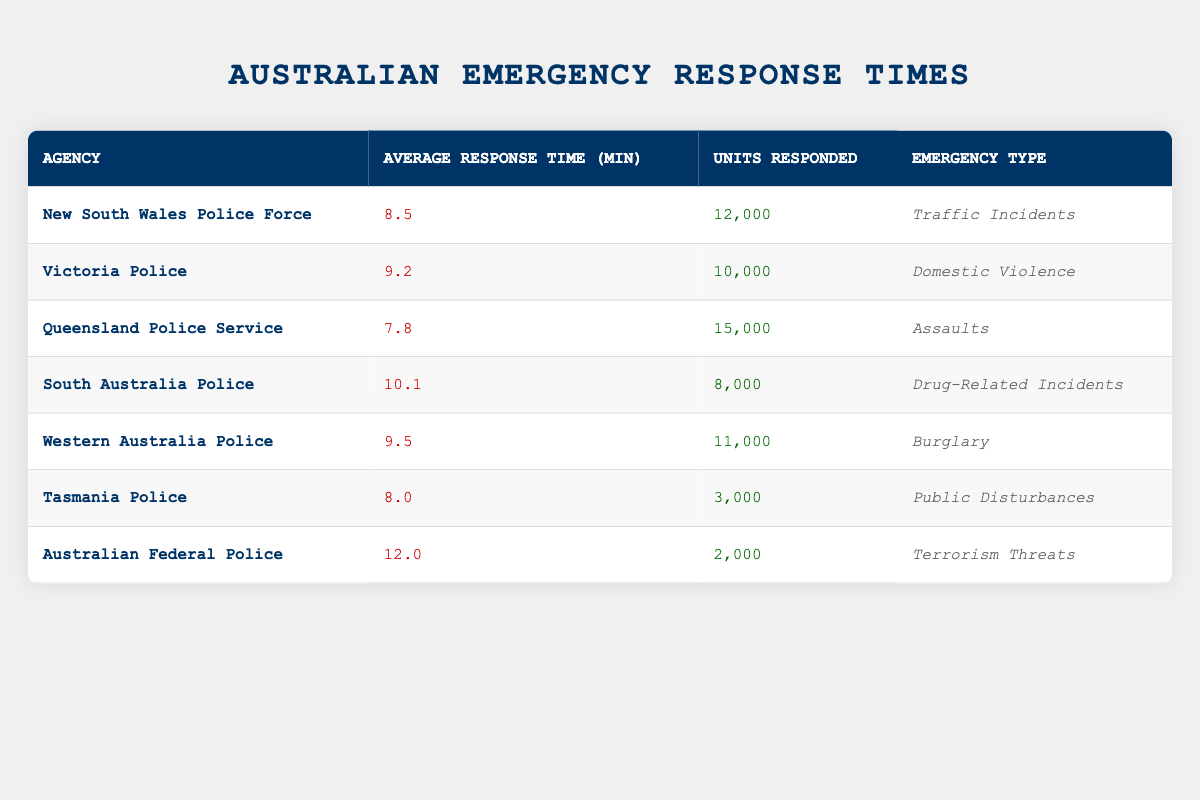What is the average response time for the Queensland Police Service? The table shows that the average response time for the Queensland Police Service is listed directly in the relevant row as 7.8 minutes.
Answer: 7.8 Which agency has the highest average response time? From the table, we see that the Australian Federal Police has the highest average response time at 12.0 minutes, as no other agency exceeds this figure.
Answer: 12.0 What is the total number of units responded by all agencies listed? To find the total, we sum the units responded by each agency: 12000 + 10000 + 15000 + 8000 + 11000 + 3000 + 2000 = 60000. Therefore, the total number of units responded is 60000.
Answer: 60000 Is it true that Tasmania Police has a shorter response time than Victoria Police? By comparing the response times in the table, Tasmania Police has an average response time of 8.0 minutes, while Victoria Police has a longer average response time of 9.2 minutes. Hence, the statement is true.
Answer: Yes What is the average response time of the agencies dealing with domestic violence and drug-related incidents? To find this average, we take the response times of Victoria Police and South Australia Police: (9.2 + 10.1) / 2 = 9.65. Thus, the average response time for these two agencies is 9.65 minutes.
Answer: 9.65 Which agency responded to the most units, and what was their average response time? The Queensland Police Service responded to the most units, with a total of 15000. Their average response time is 7.8 minutes, as indicated in the table.
Answer: Queensland Police Service; 7.8 How many agencies have an average response time greater than 9 minutes? The agencies with an average response time greater than 9 minutes are Victoria Police (9.2), South Australia Police (10.1), Western Australia Police (9.5), and Australian Federal Police (12.0). Counting these agencies gives us a total of four.
Answer: 4 What is the difference in average response time between the agency with the fastest response and the agency with the slowest response? The agency with the fastest response time is Queensland Police Service at 7.8 minutes, and the slowest is Australian Federal Police at 12.0 minutes. The difference equals 12.0 - 7.8 = 4.2 minutes.
Answer: 4.2 Which type of emergency had the lowest average response time, and what was that time? Looking at the table, the type of emergency with the lowest average response time corresponds to Queensland Police Service, which deals with assaults and has a response time of 7.8 minutes.
Answer: Assaults; 7.8 